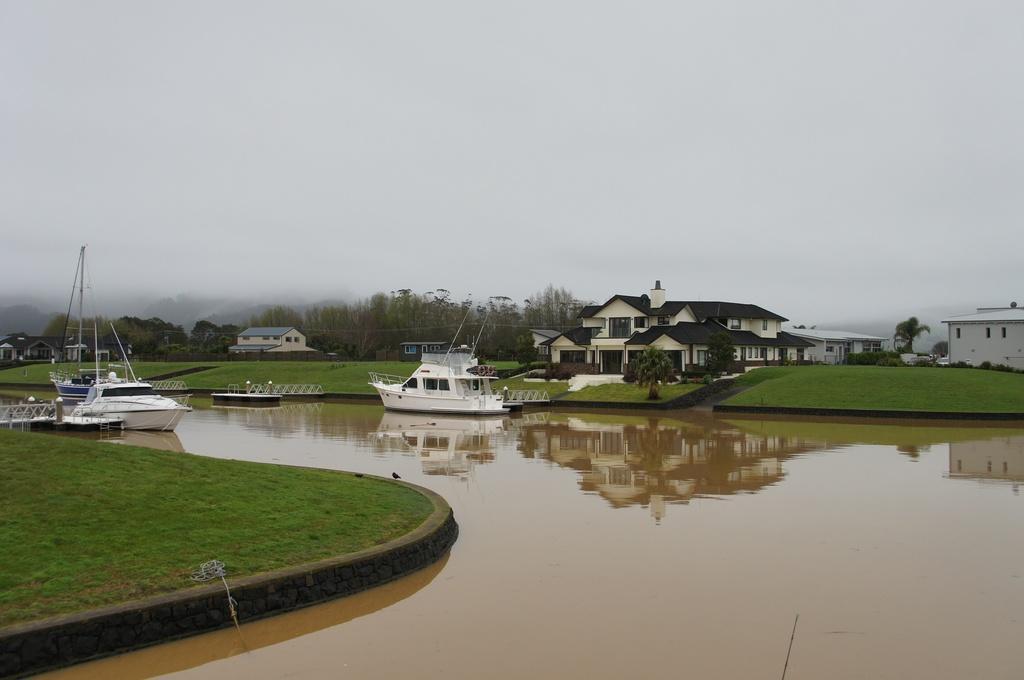Please provide a concise description of this image. In this picture we can see there are boats on the water. On the right side of the boats, there are houses, trees, grass and the sky. 